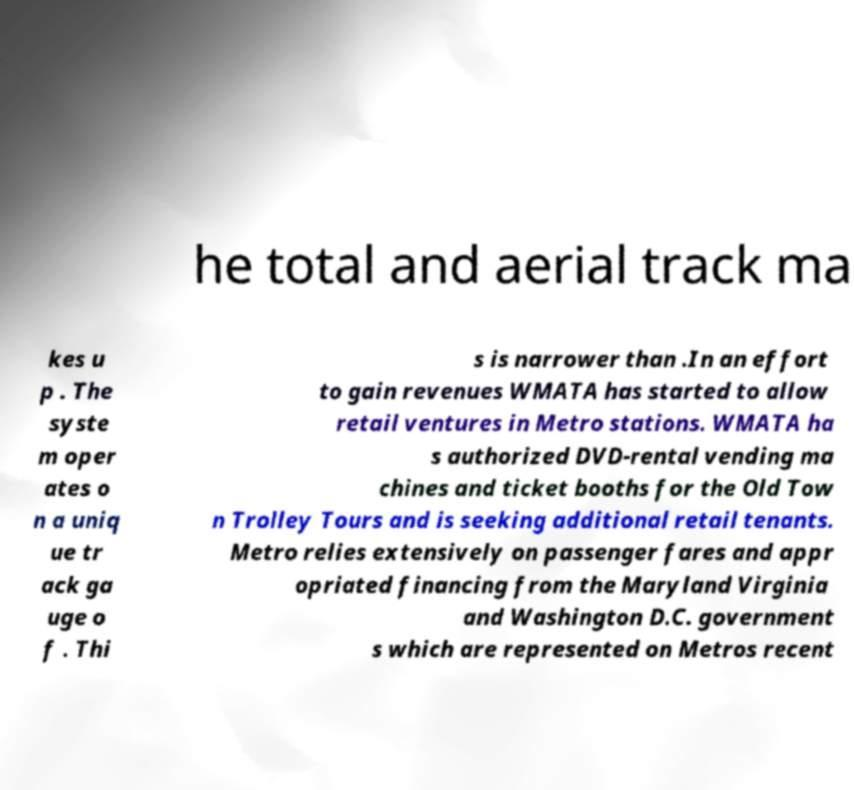I need the written content from this picture converted into text. Can you do that? he total and aerial track ma kes u p . The syste m oper ates o n a uniq ue tr ack ga uge o f . Thi s is narrower than .In an effort to gain revenues WMATA has started to allow retail ventures in Metro stations. WMATA ha s authorized DVD-rental vending ma chines and ticket booths for the Old Tow n Trolley Tours and is seeking additional retail tenants. Metro relies extensively on passenger fares and appr opriated financing from the Maryland Virginia and Washington D.C. government s which are represented on Metros recent 